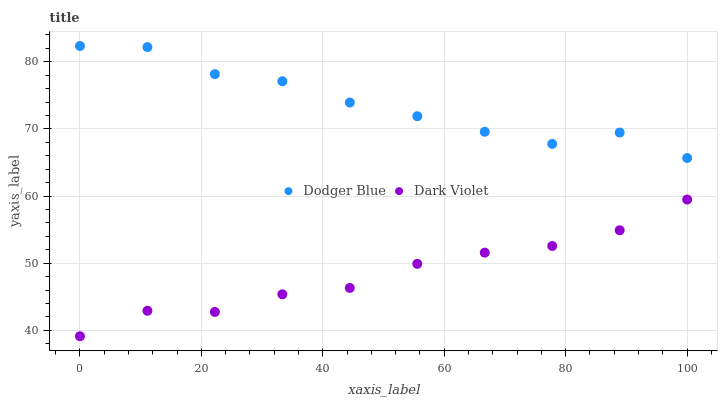Does Dark Violet have the minimum area under the curve?
Answer yes or no. Yes. Does Dodger Blue have the maximum area under the curve?
Answer yes or no. Yes. Does Dark Violet have the maximum area under the curve?
Answer yes or no. No. Is Dark Violet the smoothest?
Answer yes or no. Yes. Is Dodger Blue the roughest?
Answer yes or no. Yes. Is Dark Violet the roughest?
Answer yes or no. No. Does Dark Violet have the lowest value?
Answer yes or no. Yes. Does Dodger Blue have the highest value?
Answer yes or no. Yes. Does Dark Violet have the highest value?
Answer yes or no. No. Is Dark Violet less than Dodger Blue?
Answer yes or no. Yes. Is Dodger Blue greater than Dark Violet?
Answer yes or no. Yes. Does Dark Violet intersect Dodger Blue?
Answer yes or no. No. 